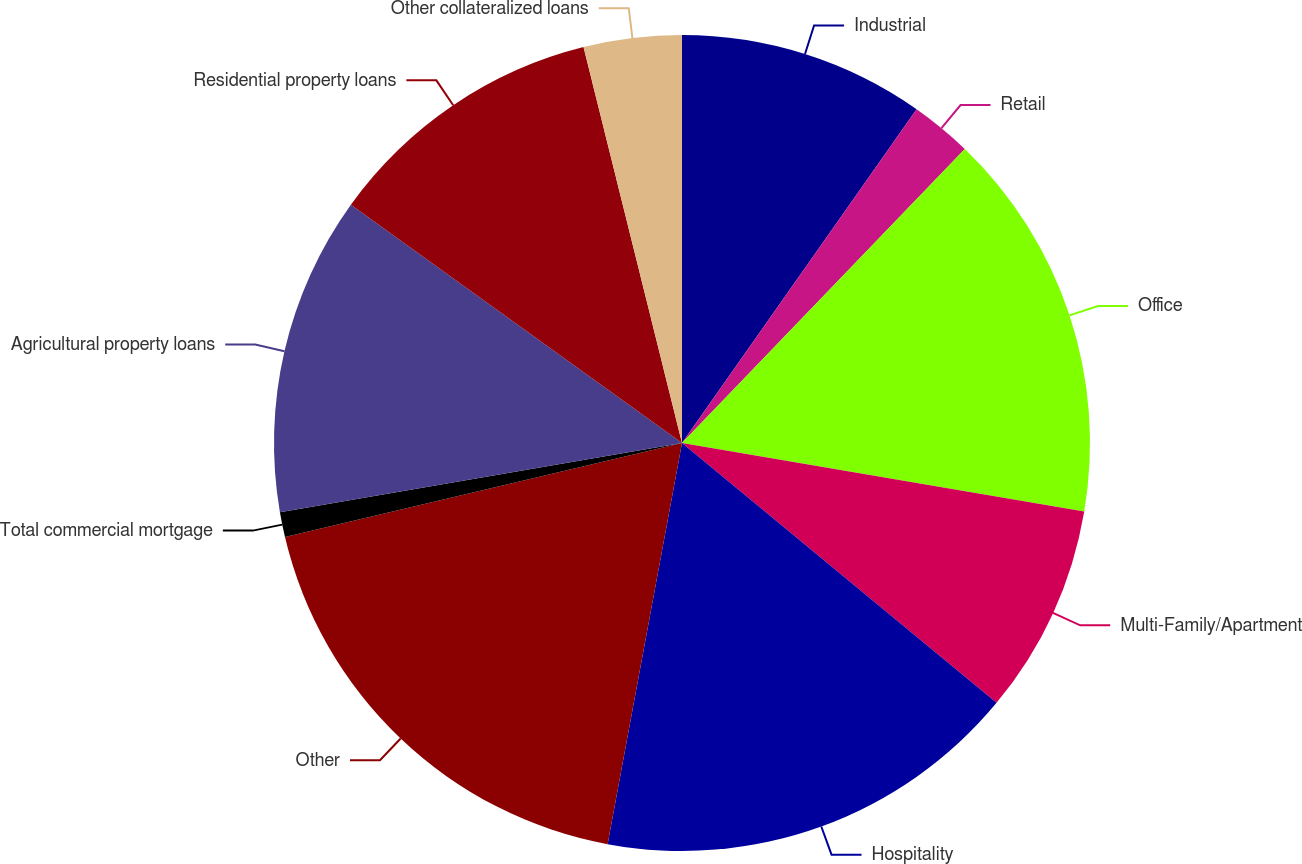Convert chart. <chart><loc_0><loc_0><loc_500><loc_500><pie_chart><fcel>Industrial<fcel>Retail<fcel>Office<fcel>Multi-Family/Apartment<fcel>Hospitality<fcel>Other<fcel>Total commercial mortgage<fcel>Agricultural property loans<fcel>Residential property loans<fcel>Other collateralized loans<nl><fcel>9.75%<fcel>2.44%<fcel>15.49%<fcel>8.31%<fcel>16.93%<fcel>18.38%<fcel>0.99%<fcel>12.64%<fcel>11.19%<fcel>3.88%<nl></chart> 